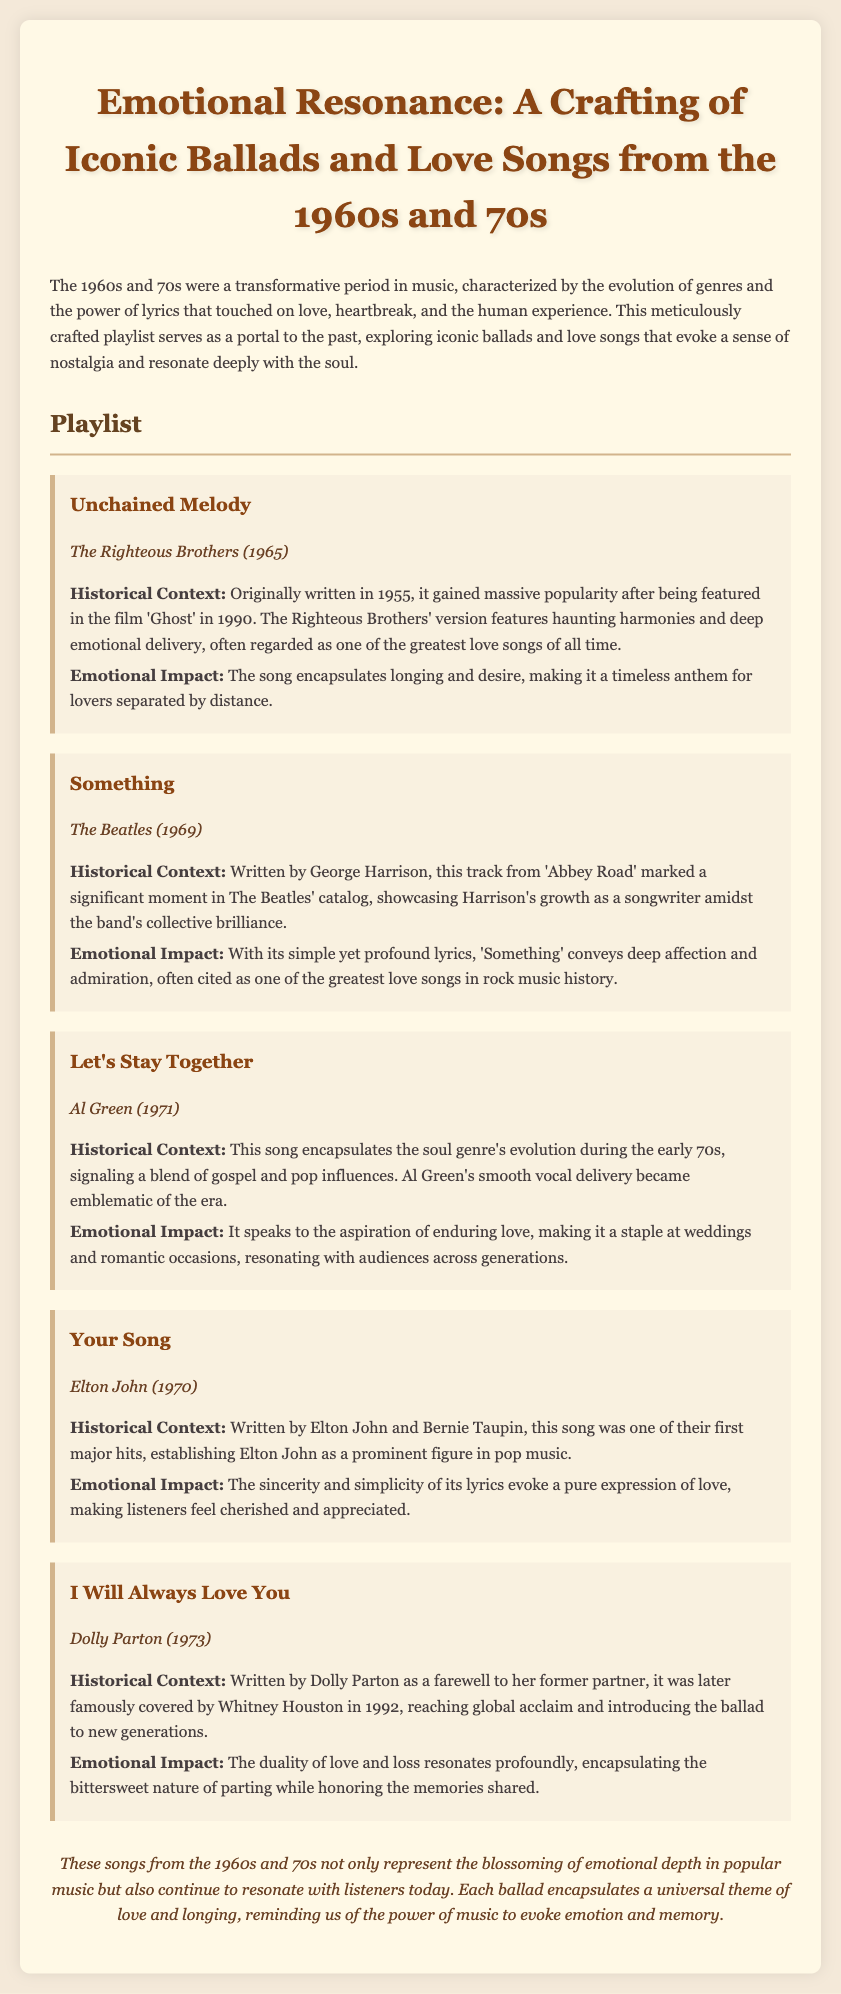what is the title of the document? The title of the document is presented prominently at the top, showcasing the subject matter of the playlist.
Answer: Emotional Resonance: A Crafting of Iconic Ballads and Love Songs from the 1960s and 70s who performed "Unchained Melody"? The document names the artist responsible for the song, highlighting its origin and significance.
Answer: The Righteous Brothers in what year was "Something" released? The release year is mentioned in the details of the song, providing historical context.
Answer: 1969 who wrote "I Will Always Love You"? The author of the song is specified in the document, indicating the historical significance of the song and its creator.
Answer: Dolly Parton what genre does "Let's Stay Together" represent? The document emphasizes the song's connection to a specific genre during a notable era in music history.
Answer: Soul how many songs are listed in the playlist? The total number of songs can be inferred from the playlist section, determining the breadth of the collection.
Answer: Five which song features "haunting harmonies"? This question requires recalling a descriptive phrase applied to one of the songs listed, indicating its emotional delivery.
Answer: Unchained Melody what is the main theme of the songs discussed? The document discusses a universal theme that runs throughout the songs, reflecting their emotional essence.
Answer: Love and longing 